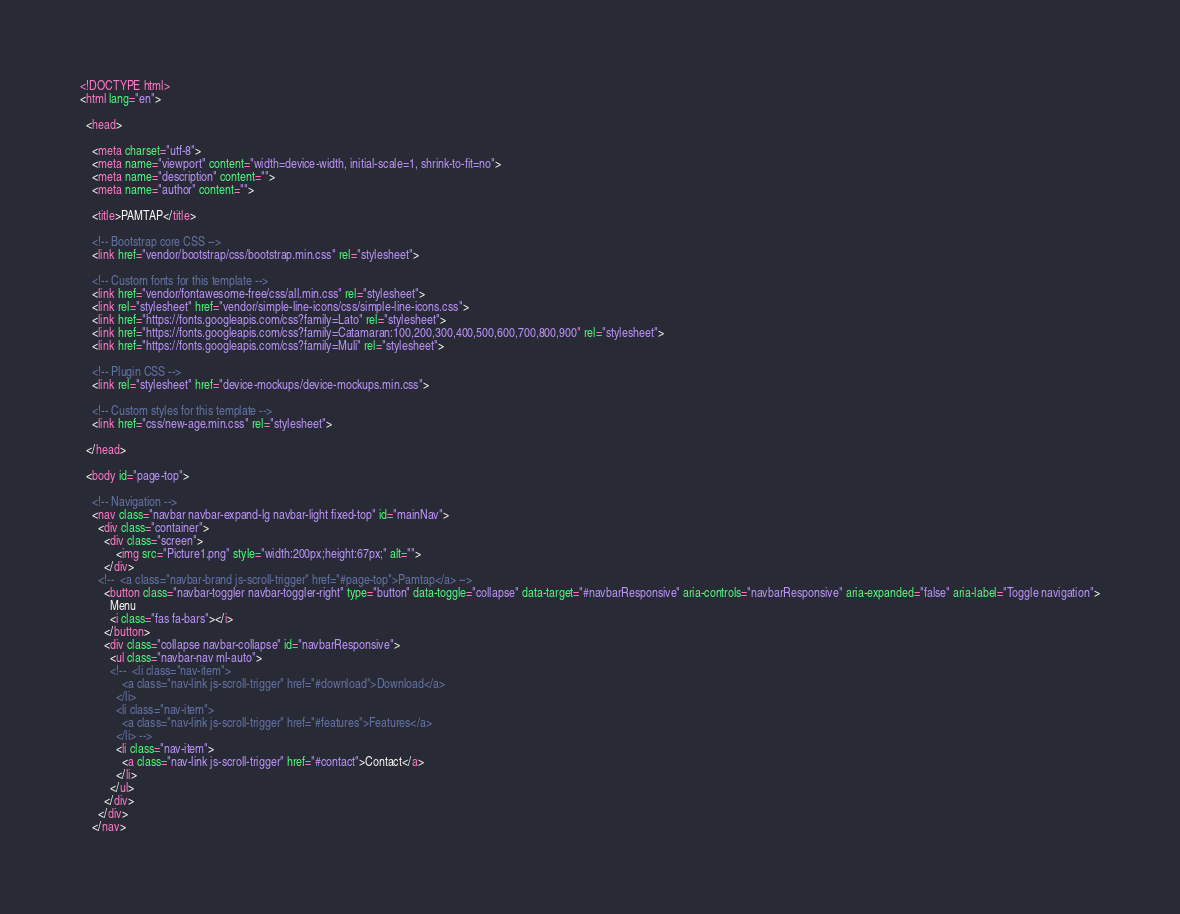<code> <loc_0><loc_0><loc_500><loc_500><_HTML_><!DOCTYPE html>
<html lang="en">

  <head>

    <meta charset="utf-8">
    <meta name="viewport" content="width=device-width, initial-scale=1, shrink-to-fit=no">
    <meta name="description" content="">
    <meta name="author" content="">

    <title>PAMTAP</title>

    <!-- Bootstrap core CSS -->
    <link href="vendor/bootstrap/css/bootstrap.min.css" rel="stylesheet">

    <!-- Custom fonts for this template -->
    <link href="vendor/fontawesome-free/css/all.min.css" rel="stylesheet">
    <link rel="stylesheet" href="vendor/simple-line-icons/css/simple-line-icons.css">
    <link href="https://fonts.googleapis.com/css?family=Lato" rel="stylesheet">
    <link href="https://fonts.googleapis.com/css?family=Catamaran:100,200,300,400,500,600,700,800,900" rel="stylesheet">
    <link href="https://fonts.googleapis.com/css?family=Muli" rel="stylesheet">

    <!-- Plugin CSS -->
    <link rel="stylesheet" href="device-mockups/device-mockups.min.css">

    <!-- Custom styles for this template -->
    <link href="css/new-age.min.css" rel="stylesheet">

  </head>

  <body id="page-top">

    <!-- Navigation -->
    <nav class="navbar navbar-expand-lg navbar-light fixed-top" id="mainNav">
      <div class="container">
        <div class="screen">
            <img src="Picture1.png" style="width:200px;height:67px;" alt="">
        </div>
      <!--  <a class="navbar-brand js-scroll-trigger" href="#page-top">Pamtap</a> -->
        <button class="navbar-toggler navbar-toggler-right" type="button" data-toggle="collapse" data-target="#navbarResponsive" aria-controls="navbarResponsive" aria-expanded="false" aria-label="Toggle navigation">
          Menu
          <i class="fas fa-bars"></i>
        </button>
        <div class="collapse navbar-collapse" id="navbarResponsive">
          <ul class="navbar-nav ml-auto">
          <!--  <li class="nav-item">
              <a class="nav-link js-scroll-trigger" href="#download">Download</a>
            </li>
            <li class="nav-item">
              <a class="nav-link js-scroll-trigger" href="#features">Features</a>
            </li> -->
            <li class="nav-item">
              <a class="nav-link js-scroll-trigger" href="#contact">Contact</a>
            </li>
          </ul>
        </div>
      </div>
    </nav>
</code> 